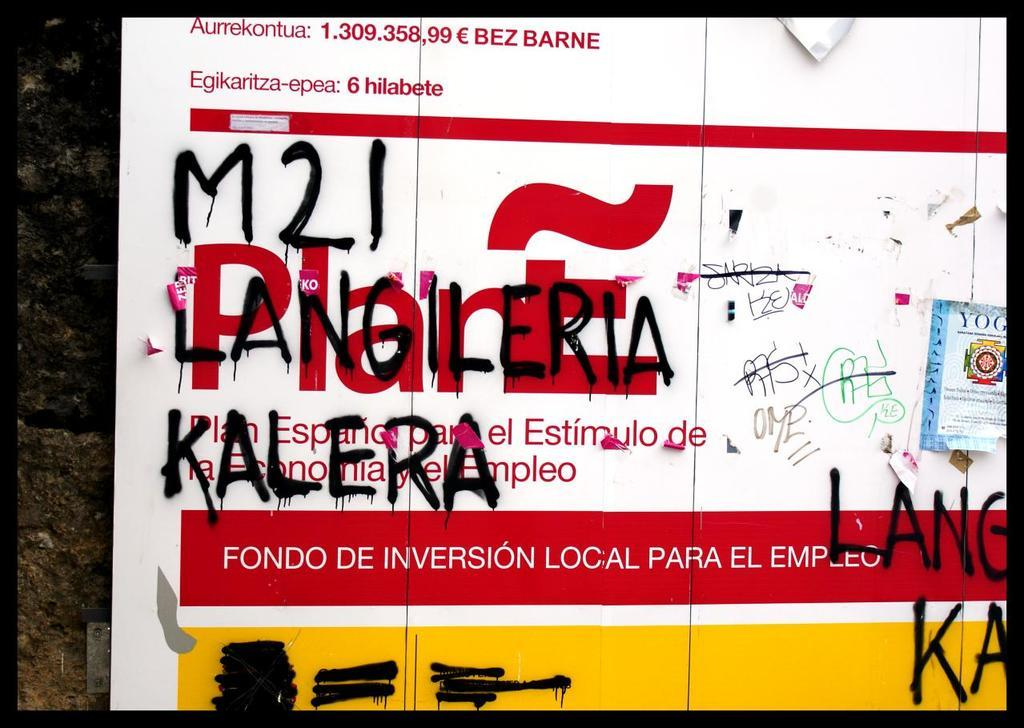<image>
Present a compact description of the photo's key features. A white and red advertisement written over it in black spray paint that reads M21 Langileria Kalera. 